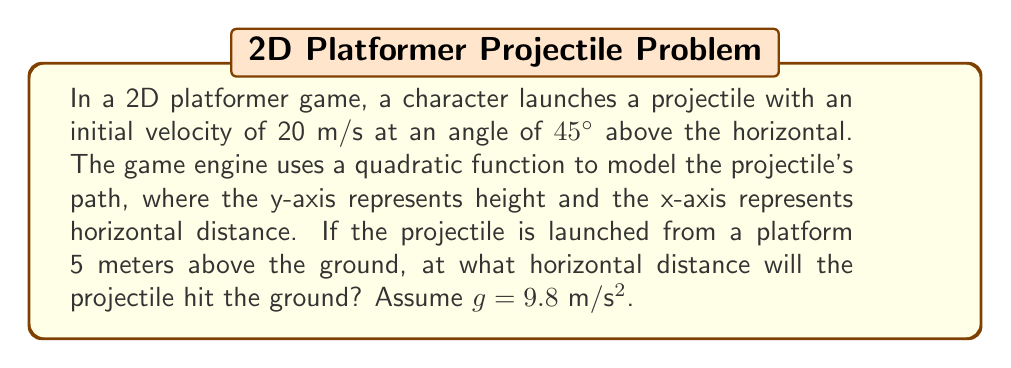Solve this math problem. Let's approach this step-by-step:

1) The quadratic function for projectile motion is:

   $$y = -\frac{1}{2}g(\frac{x}{v_x})^2 + (tan\theta)x + h_0$$

   Where:
   $y$ is the vertical position
   $x$ is the horizontal position
   $g$ is the acceleration due to gravity (9.8 m/s²)
   $v_x$ is the horizontal component of initial velocity
   $\theta$ is the launch angle
   $h_0$ is the initial height

2) Calculate $v_x$:
   $$v_x = v \cos\theta = 20 \cos(45°) = 20 \cdot \frac{\sqrt{2}}{2} \approx 14.14 \text{ m/s}$$

3) Substitute the known values into the equation:

   $$y = -\frac{1}{2}(9.8)(\frac{x}{14.14})^2 + (\tan 45°)x + 5$$

4) Simplify:

   $$y = -0.0245x^2 + x + 5$$

5) To find where the projectile hits the ground, set $y = 0$:

   $$0 = -0.0245x^2 + x + 5$$

6) Rearrange to standard form:

   $$0.0245x^2 - x - 5 = 0$$

7) Use the quadratic formula: $x = \frac{-b \pm \sqrt{b^2 - 4ac}}{2a}$

   $$x = \frac{1 \pm \sqrt{1^2 - 4(0.0245)(-5)}}{2(0.0245)}$$

8) Solve:

   $$x \approx 45.92 \text{ or } -4.41$$

9) Since negative distance doesn't make sense in this context, the projectile hits the ground at approximately 45.92 meters.
Answer: 45.92 m 